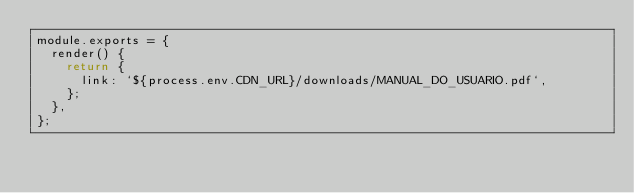Convert code to text. <code><loc_0><loc_0><loc_500><loc_500><_JavaScript_>module.exports = {
  render() {
    return {
      link: `${process.env.CDN_URL}/downloads/MANUAL_DO_USUARIO.pdf`,
    };
  },
};
</code> 